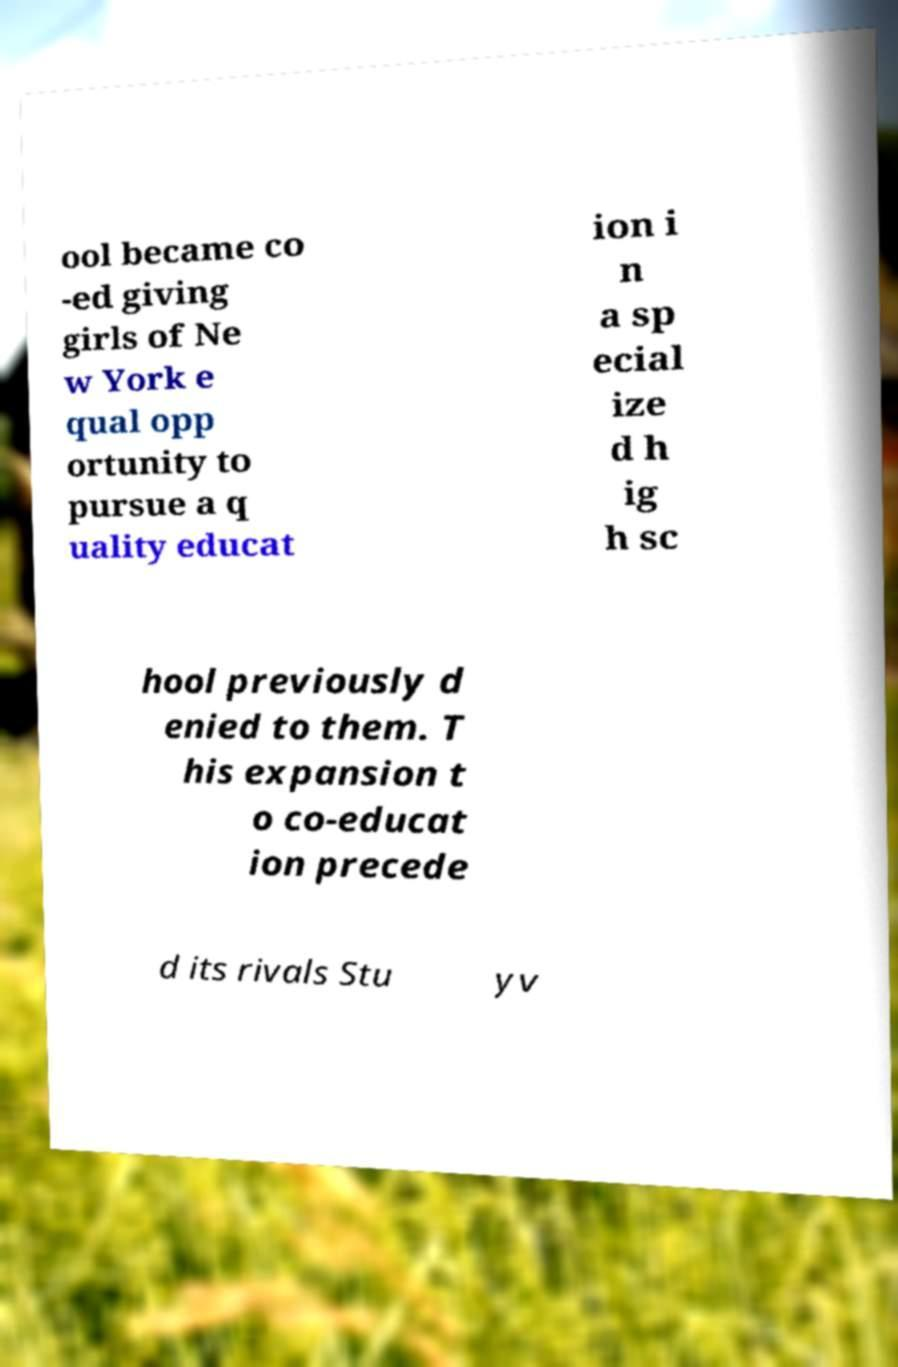Could you extract and type out the text from this image? ool became co -ed giving girls of Ne w York e qual opp ortunity to pursue a q uality educat ion i n a sp ecial ize d h ig h sc hool previously d enied to them. T his expansion t o co-educat ion precede d its rivals Stu yv 